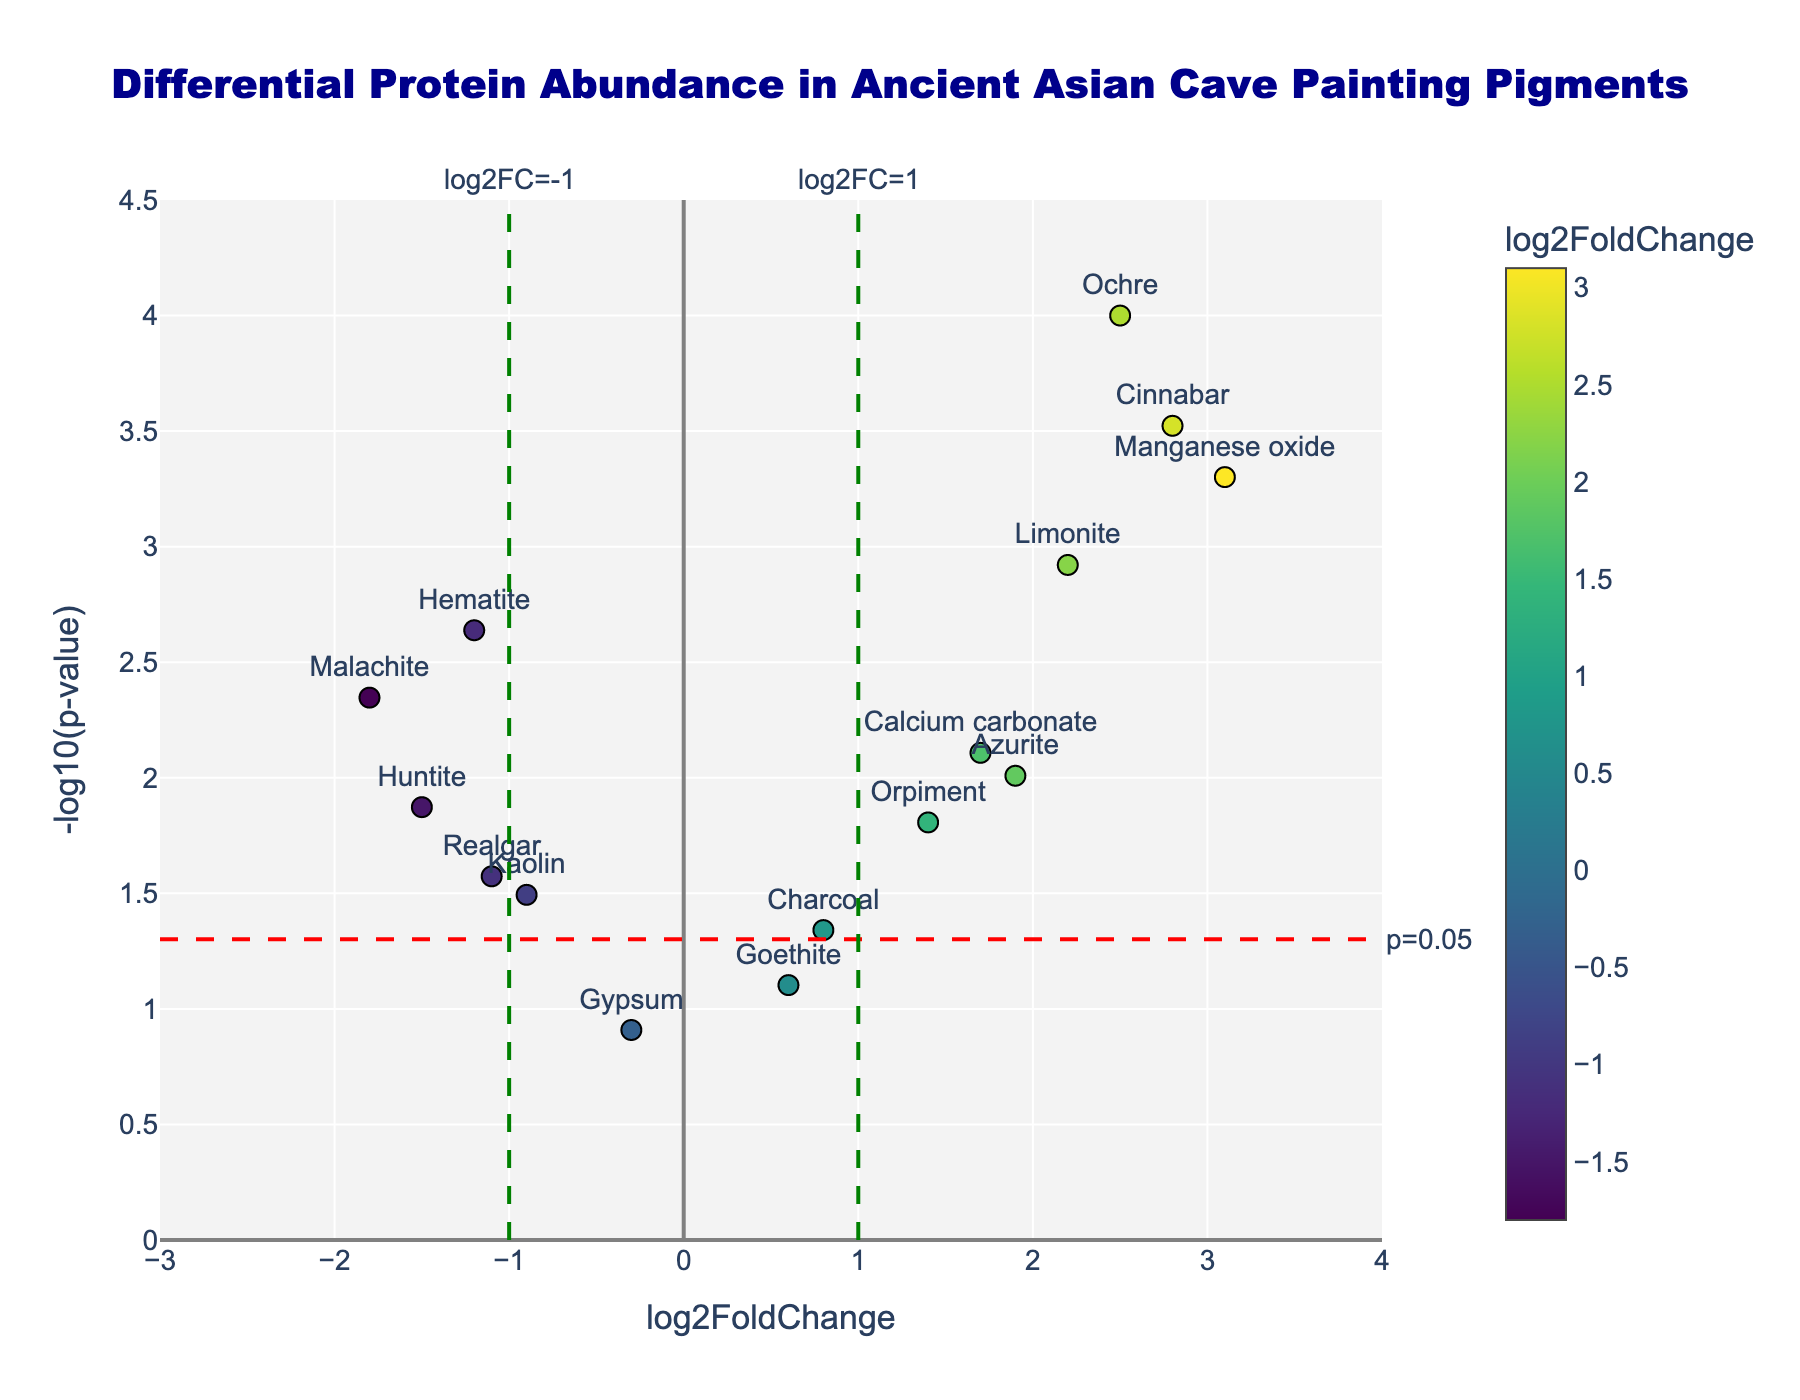What is the title of the figure? The title is usually positioned at the top center of the figure and can be identified without any ambiguity.
Answer: Differential Protein Abundance in Ancient Asian Cave Painting Pigments How many data points are there in the plot? By counting each unique marker on the scatter plot, we can determine the total number of data points.
Answer: 15 Which pigment has the highest p-value? The highest p-value corresponds to the smallest -log10(p-value). Visually, this data point is the lowest along the y-axis. From the hovertext or data, the pigment can be identified.
Answer: Gypsum Which pigment shows the highest log2FoldChange? The highest log2FoldChange will be the point furthest to the right on the x-axis. Hover over the plot or use the data table to identify the pigment.
Answer: Manganese oxide Is there any pigment with a log2FoldChange less than -1 and a p-value less than 0.05? We find points to the left of the vertical line at log2FoldChange = -1 and below the horizontal line at -log10(p-value) = 1.3010. The data points in this region satisfy both conditions.
Answer: Yes How many pigments have a p-value less than 0.05? By identifying the points above the horizontal threshold line at y = 1.3010, we can count the number of such points.
Answer: 10 Which pigment has the second highest -log10(p-value)? After identifying the highest -log10(p-value) point, find the next highest point vertically. Use hovertext or data to identify it.
Answer: Cinnabar Among Hematite, Ochre, and Charcoal, which has the smallest p-value? By comparing their positions vertically along the y-axis, the pigment with the highest vertical position will have the smallest p-value.
Answer: Ochre Which pigments have a log2FoldChange between -1 and 1? Identify data points between the two vertical lines at log2FoldChange = -1 and log2FoldChange = 1. The points within this range fall between these lines.
Answer: Gypsum, Charcoal, Goethite 